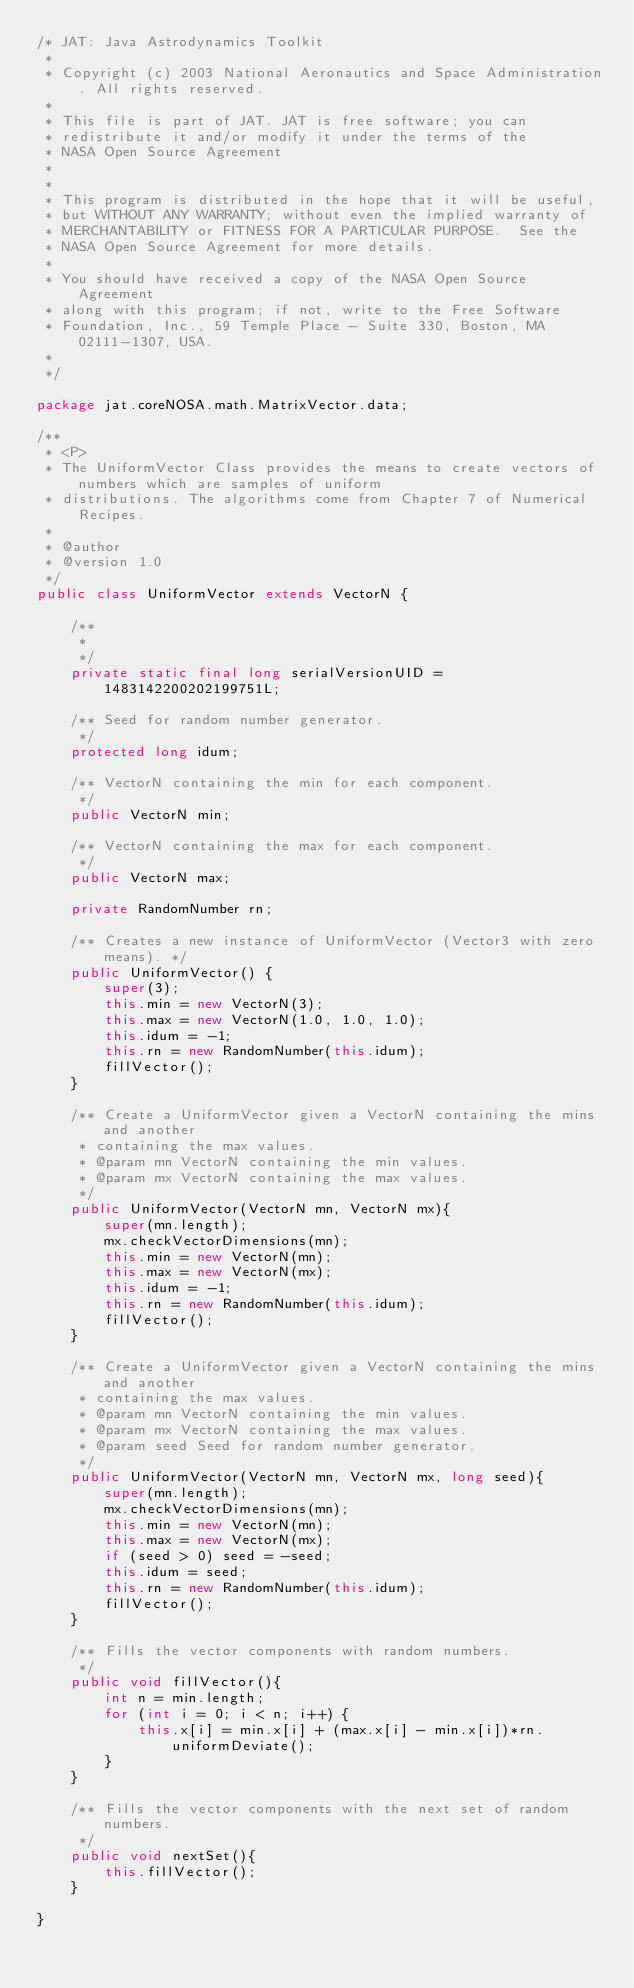<code> <loc_0><loc_0><loc_500><loc_500><_Java_>/* JAT: Java Astrodynamics Toolkit
 *
 * Copyright (c) 2003 National Aeronautics and Space Administration. All rights reserved.
 *
 * This file is part of JAT. JAT is free software; you can 
 * redistribute it and/or modify it under the terms of the 
 * NASA Open Source Agreement 
 * 
 *
 * This program is distributed in the hope that it will be useful,
 * but WITHOUT ANY WARRANTY; without even the implied warranty of
 * MERCHANTABILITY or FITNESS FOR A PARTICULAR PURPOSE.  See the
 * NASA Open Source Agreement for more details.
 *
 * You should have received a copy of the NASA Open Source Agreement
 * along with this program; if not, write to the Free Software
 * Foundation, Inc., 59 Temple Place - Suite 330, Boston, MA  02111-1307, USA.
 *
 */

package jat.coreNOSA.math.MatrixVector.data;

/**
 * <P>
 * The UniformVector Class provides the means to create vectors of numbers which are samples of uniform
 * distributions. The algorithms come from Chapter 7 of Numerical Recipes.
 *
 * @author 
 * @version 1.0
 */
public class UniformVector extends VectorN {
    
    /**
	 * 
	 */
	private static final long serialVersionUID = 1483142200202199751L;

	/** Seed for random number generator.
     */    
    protected long idum;

    /** VectorN containing the min for each component.
     */    
    public VectorN min;

    /** VectorN containing the max for each component.
     */    
    public VectorN max;
    
    private RandomNumber rn;    
    
    /** Creates a new instance of UniformVector (Vector3 with zero means). */
    public UniformVector() {
        super(3);
        this.min = new VectorN(3);
        this.max = new VectorN(1.0, 1.0, 1.0);
        this.idum = -1;
        this.rn = new RandomNumber(this.idum);
        fillVector();
    }
    
    /** Create a UniformVector given a VectorN containing the mins and another
     * containing the max values.
     * @param mn VectorN containing the min values.
     * @param mx VectorN containing the max values.
     */
    public UniformVector(VectorN mn, VectorN mx){
        super(mn.length);
        mx.checkVectorDimensions(mn);
        this.min = new VectorN(mn);
        this.max = new VectorN(mx);
        this.idum = -1;
        this.rn = new RandomNumber(this.idum);        
        fillVector();
    }
    
    /** Create a UniformVector given a VectorN containing the mins and another
     * containing the max values.
     * @param mn VectorN containing the min values.
     * @param mx VectorN containing the max values.
     * @param seed Seed for random number generator.
     */
    public UniformVector(VectorN mn, VectorN mx, long seed){
        super(mn.length);
        mx.checkVectorDimensions(mn);
        this.min = new VectorN(mn);
        this.max = new VectorN(mx);
        if (seed > 0) seed = -seed;
        this.idum = seed;
        this.rn = new RandomNumber(this.idum);        
        fillVector();
    }
    
    /** Fills the vector components with random numbers.
     */    
    public void fillVector(){
        int n = min.length;
        for (int i = 0; i < n; i++) {
            this.x[i] = min.x[i] + (max.x[i] - min.x[i])*rn.uniformDeviate();
        }
    }

    /** Fills the vector components with the next set of random numbers.
     */
    public void nextSet(){
        this.fillVector();
    }
    
}
</code> 